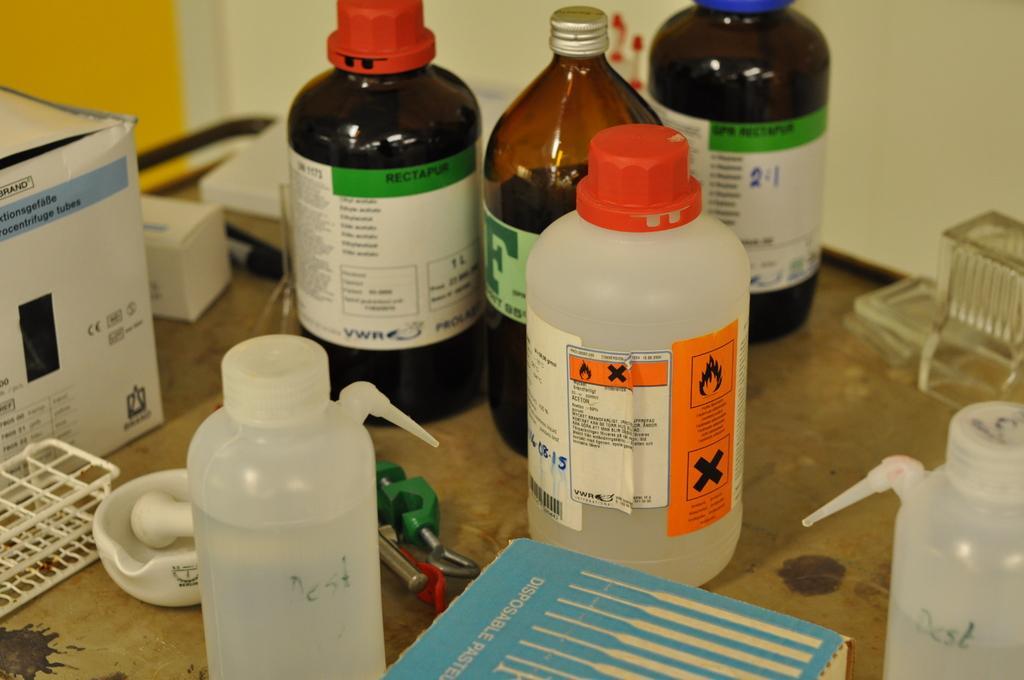Could you give a brief overview of what you see in this image? In this image there are group of bottles placed on a table. This is a paper box and this is a bowl. Some other objects are also placed on the table. This looks like a plastic box. There are three glass bottles and three plastic bottles on the table. 